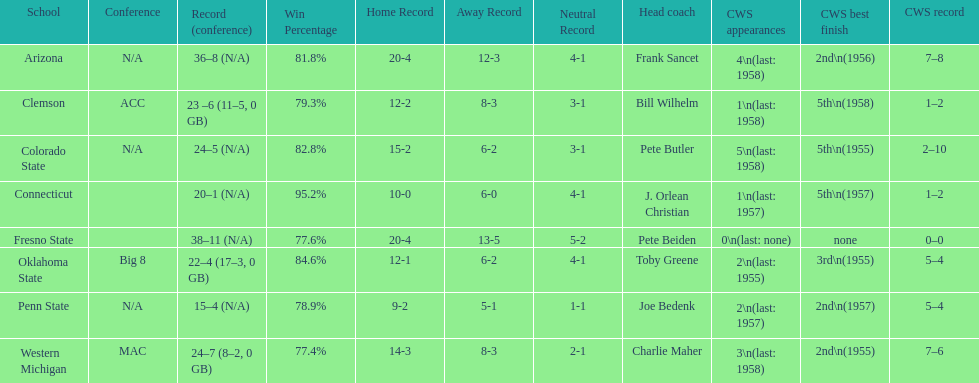What are the number of schools with more than 2 cws appearances? 3. 